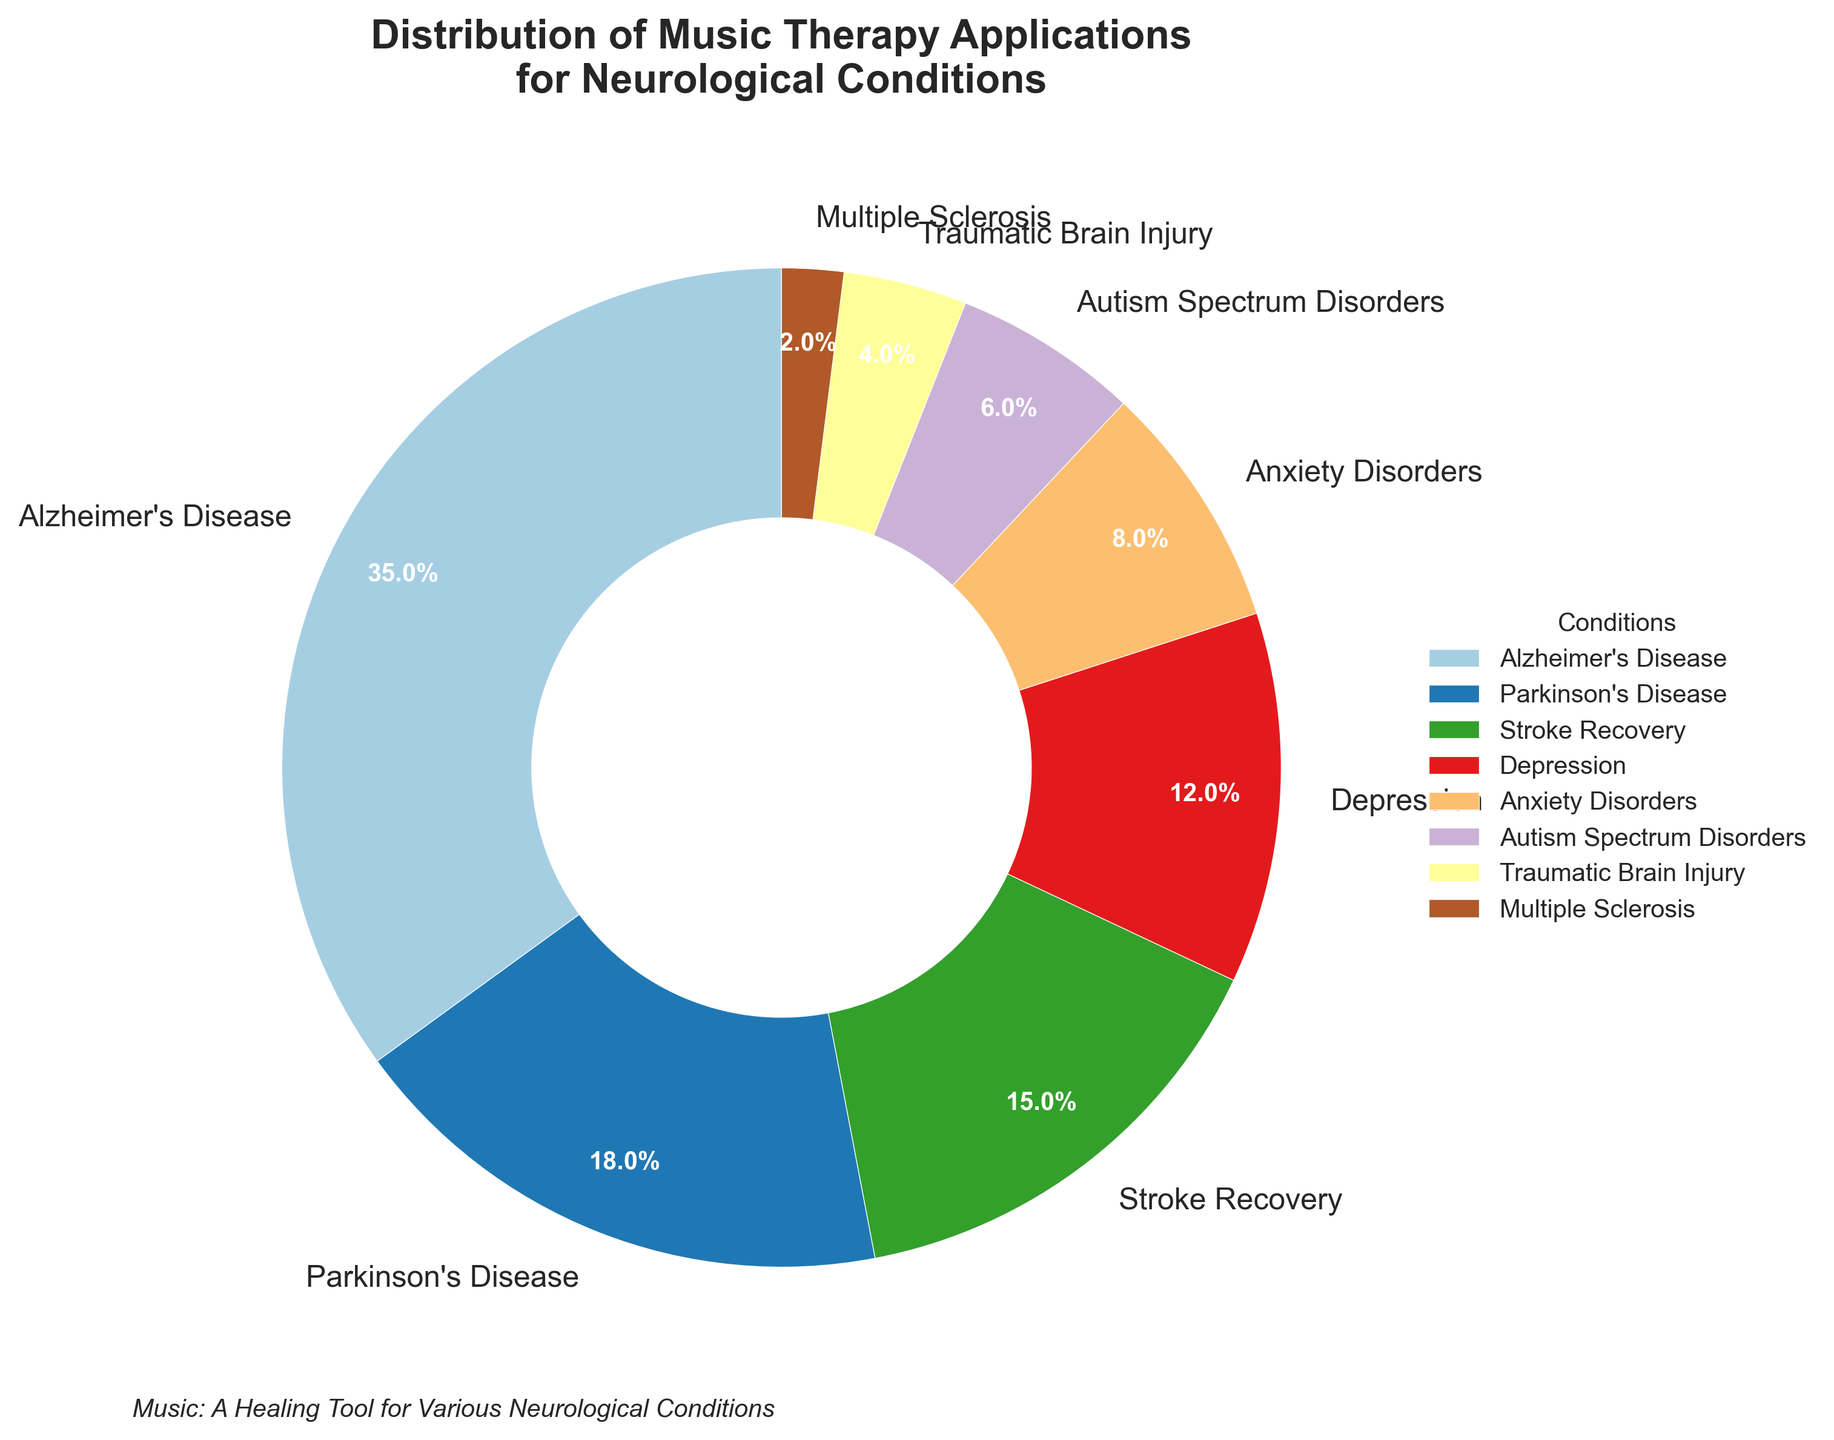What's the most common neurological condition receiving music therapy? According to the pie chart, Alzheimer's Disease has the highest percentage at 35%, marking it as the most common condition receiving music therapy.
Answer: Alzheimer's Disease How does the application of music therapy for Alzheimer's compare to that for Parkinson's? Alzheimer's Disease receives 35% of music therapy applications, whereas Parkinson's Disease receives 18%. By subtraction, Alzheimer's accounts for 17% more than Parkinson's.
Answer: 17% What is the combined percentage of music therapy applications for Stroke Recovery and Depression? Stroke Recovery has 15% and Depression has 12%. Adding these two percentages gives 15% + 12% = 27%.
Answer: 27% Which neurological condition has the least share of music therapy applications? The pie chart indicates that Multiple Sclerosis has the smallest share, accounting for only 2% of music therapy applications.
Answer: Multiple Sclerosis Is the percentage of music therapy applications for Autism Spectrum Disorders greater than for Traumatic Brain Injury? The pie chart shows Autism Spectrum Disorders at 6% and Traumatic Brain Injury at 4%. Comparing these two, Autism Spectrum Disorders has a higher percentage.
Answer: Yes What is the difference between the percentage of music therapy applications for Anxiety Disorders and Autism Spectrum Disorders? Anxiety Disorders account for 8% and Autism Spectrum Disorders 6%. The difference is 8% - 6% = 2%.
Answer: 2% What is the total percentage of music therapy applications dedicated to Alzheimer's Disease, Parkinson's Disease, and Stroke Recovery? Adding the percentages: Alzheimer's Disease (35%) + Parkinson's Disease (18%) + Stroke Recovery (15%) = 68%.
Answer: 68% How much more common is music therapy for Depression compared to Multiple Sclerosis? Depression receives 12% of music therapy applications, while Multiple Sclerosis gets 2%. The difference is 12% - 2% = 10%.
Answer: 10% Which conditions collectively account for less than 10% of the total music therapy applications? According to the pie chart, Traumatic Brain Injury (4%) and Multiple Sclerosis (2%) add up to 6%, which is less than 10%.
Answer: Traumatic Brain Injury and Multiple Sclerosis 